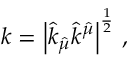<formula> <loc_0><loc_0><loc_500><loc_500>k = \left | \hat { k } _ { \hat { \mu } } \hat { k } ^ { \hat { \mu } } \right | ^ { \frac { 1 } { 2 } } \, ,</formula> 